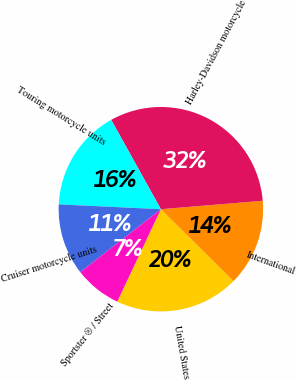<chart> <loc_0><loc_0><loc_500><loc_500><pie_chart><fcel>United States<fcel>International<fcel>Harley-Davidson motorcycle<fcel>Touring motorcycle units<fcel>Cruiser motorcycle units<fcel>Sportster ® / Street<nl><fcel>19.59%<fcel>13.74%<fcel>31.76%<fcel>16.17%<fcel>11.31%<fcel>7.43%<nl></chart> 